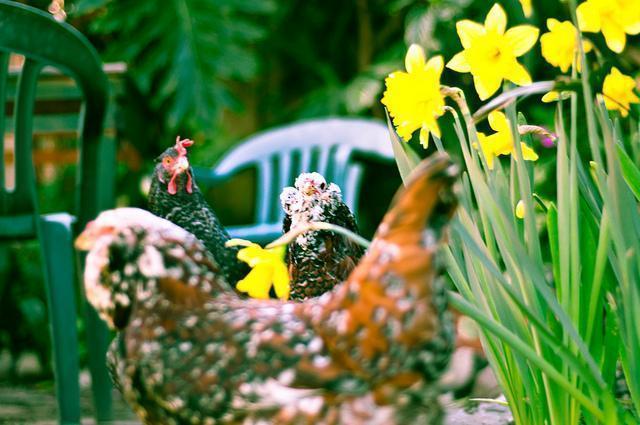What animal is near the flowers?
Choose the correct response, then elucidate: 'Answer: answer
Rationale: rationale.'
Options: Dog, rooster, cat, cow. Answer: rooster.
Rationale: There is a rooster near the flowers that has black feathers and a red thing on his head. 